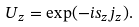<formula> <loc_0><loc_0><loc_500><loc_500>U _ { z } = \exp ( - i s _ { z } j _ { z } ) .</formula> 